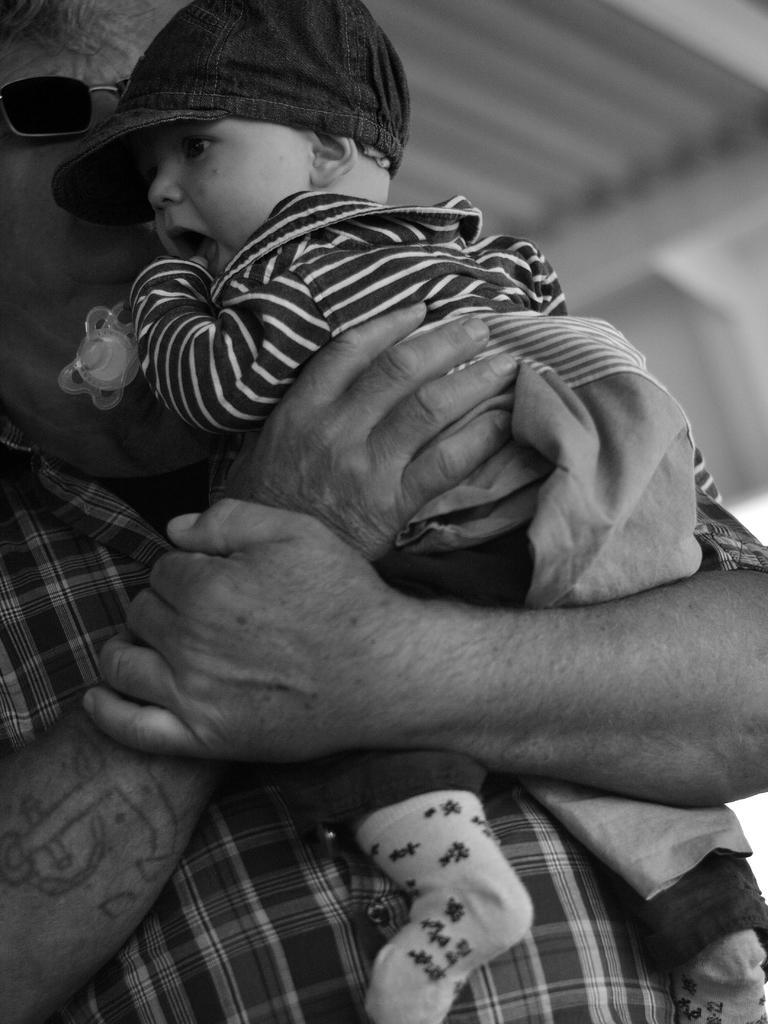Please provide a concise description of this image. This is a black and white pic. We can see a man is holding a kid in his hands and the kid is holding an object in the hands. In the background the image is blur but we can see an object. 